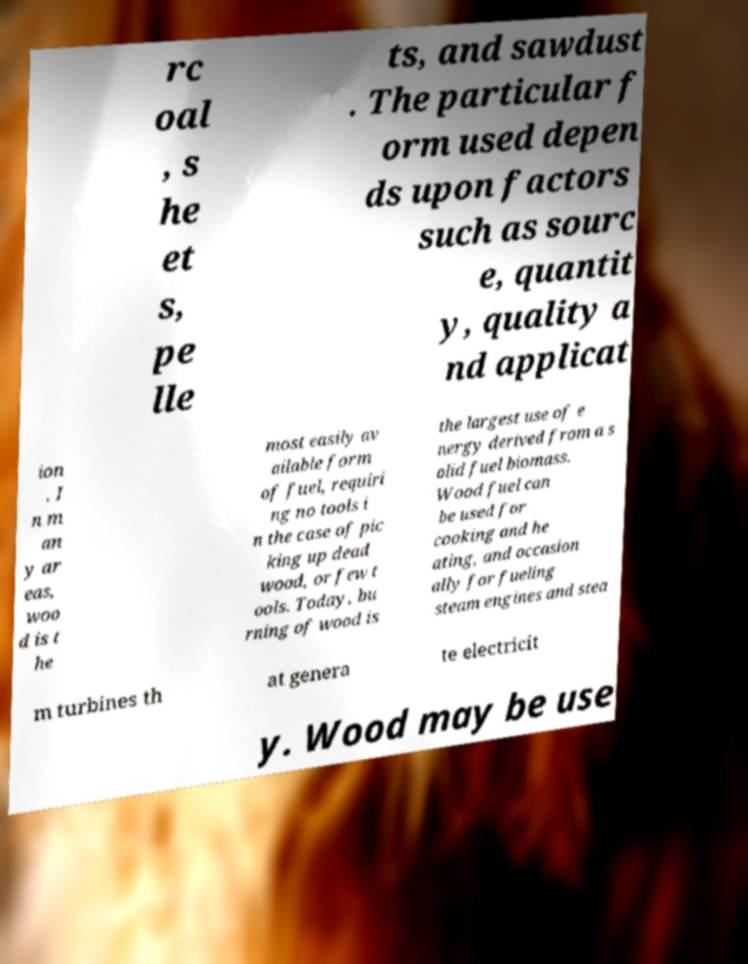Please read and relay the text visible in this image. What does it say? rc oal , s he et s, pe lle ts, and sawdust . The particular f orm used depen ds upon factors such as sourc e, quantit y, quality a nd applicat ion . I n m an y ar eas, woo d is t he most easily av ailable form of fuel, requiri ng no tools i n the case of pic king up dead wood, or few t ools. Today, bu rning of wood is the largest use of e nergy derived from a s olid fuel biomass. Wood fuel can be used for cooking and he ating, and occasion ally for fueling steam engines and stea m turbines th at genera te electricit y. Wood may be use 